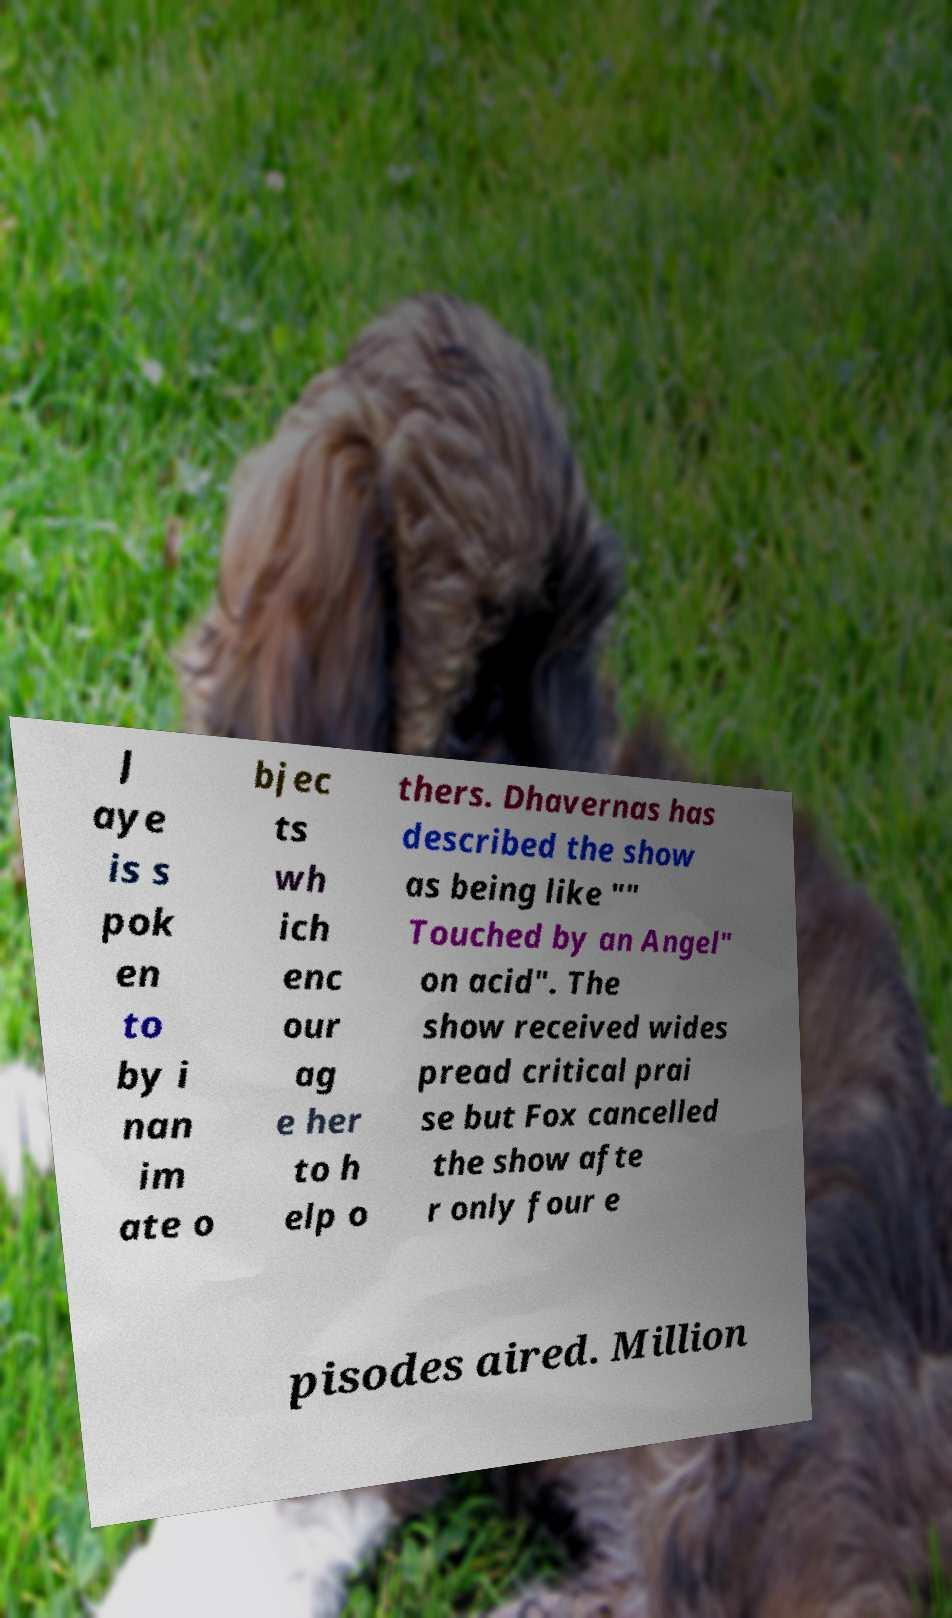Can you accurately transcribe the text from the provided image for me? J aye is s pok en to by i nan im ate o bjec ts wh ich enc our ag e her to h elp o thers. Dhavernas has described the show as being like "" Touched by an Angel" on acid". The show received wides pread critical prai se but Fox cancelled the show afte r only four e pisodes aired. Million 